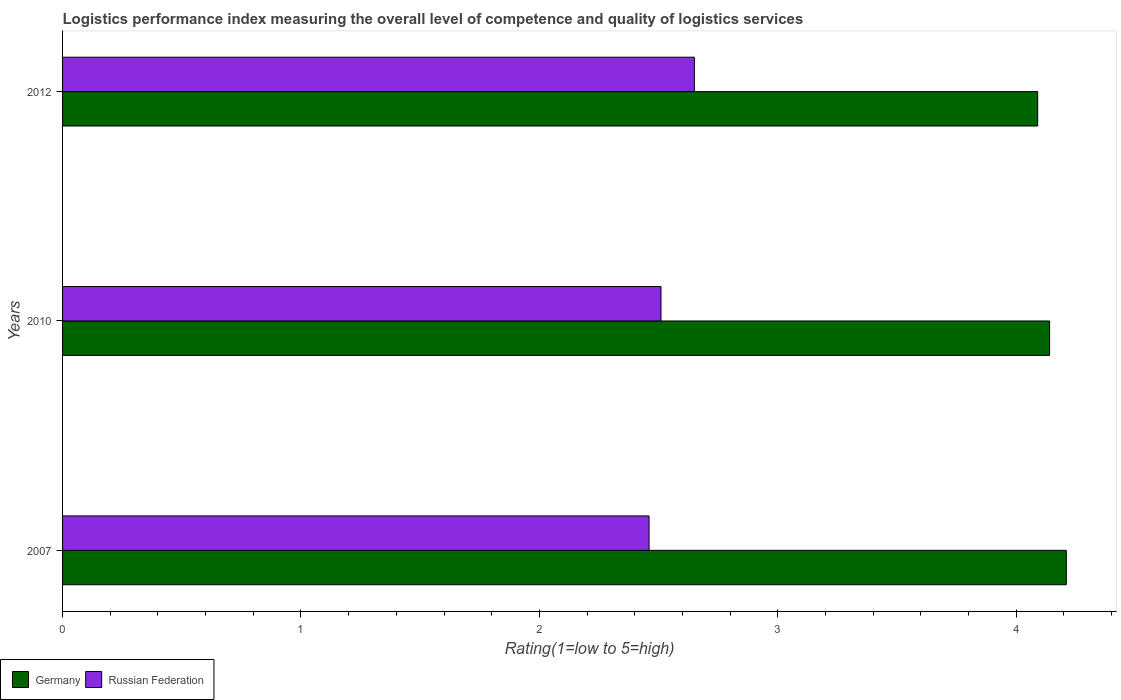How many different coloured bars are there?
Give a very brief answer. 2. How many groups of bars are there?
Your answer should be compact. 3. How many bars are there on the 3rd tick from the top?
Provide a short and direct response. 2. In how many cases, is the number of bars for a given year not equal to the number of legend labels?
Offer a very short reply. 0. What is the Logistic performance index in Germany in 2007?
Provide a succinct answer. 4.21. Across all years, what is the maximum Logistic performance index in Germany?
Provide a short and direct response. 4.21. Across all years, what is the minimum Logistic performance index in Russian Federation?
Make the answer very short. 2.46. In which year was the Logistic performance index in Germany maximum?
Keep it short and to the point. 2007. What is the total Logistic performance index in Germany in the graph?
Give a very brief answer. 12.44. What is the difference between the Logistic performance index in Germany in 2010 and that in 2012?
Provide a short and direct response. 0.05. What is the difference between the Logistic performance index in Germany in 2007 and the Logistic performance index in Russian Federation in 2012?
Your answer should be very brief. 1.56. What is the average Logistic performance index in Germany per year?
Your response must be concise. 4.15. In the year 2012, what is the difference between the Logistic performance index in Germany and Logistic performance index in Russian Federation?
Offer a terse response. 1.44. In how many years, is the Logistic performance index in Germany greater than 0.8 ?
Offer a very short reply. 3. What is the ratio of the Logistic performance index in Russian Federation in 2007 to that in 2010?
Provide a succinct answer. 0.98. Is the Logistic performance index in Russian Federation in 2007 less than that in 2012?
Keep it short and to the point. Yes. What is the difference between the highest and the second highest Logistic performance index in Germany?
Provide a short and direct response. 0.07. What is the difference between the highest and the lowest Logistic performance index in Russian Federation?
Ensure brevity in your answer.  0.19. Is the sum of the Logistic performance index in Germany in 2010 and 2012 greater than the maximum Logistic performance index in Russian Federation across all years?
Offer a terse response. Yes. What does the 2nd bar from the top in 2010 represents?
Ensure brevity in your answer.  Germany. What does the 2nd bar from the bottom in 2012 represents?
Your answer should be very brief. Russian Federation. How many bars are there?
Your response must be concise. 6. How many years are there in the graph?
Provide a short and direct response. 3. Are the values on the major ticks of X-axis written in scientific E-notation?
Ensure brevity in your answer.  No. Does the graph contain any zero values?
Offer a terse response. No. Where does the legend appear in the graph?
Offer a very short reply. Bottom left. What is the title of the graph?
Offer a terse response. Logistics performance index measuring the overall level of competence and quality of logistics services. What is the label or title of the X-axis?
Offer a very short reply. Rating(1=low to 5=high). What is the label or title of the Y-axis?
Your response must be concise. Years. What is the Rating(1=low to 5=high) of Germany in 2007?
Your response must be concise. 4.21. What is the Rating(1=low to 5=high) of Russian Federation in 2007?
Your response must be concise. 2.46. What is the Rating(1=low to 5=high) of Germany in 2010?
Your response must be concise. 4.14. What is the Rating(1=low to 5=high) of Russian Federation in 2010?
Your answer should be compact. 2.51. What is the Rating(1=low to 5=high) in Germany in 2012?
Ensure brevity in your answer.  4.09. What is the Rating(1=low to 5=high) of Russian Federation in 2012?
Your answer should be compact. 2.65. Across all years, what is the maximum Rating(1=low to 5=high) in Germany?
Offer a very short reply. 4.21. Across all years, what is the maximum Rating(1=low to 5=high) in Russian Federation?
Ensure brevity in your answer.  2.65. Across all years, what is the minimum Rating(1=low to 5=high) of Germany?
Your answer should be very brief. 4.09. Across all years, what is the minimum Rating(1=low to 5=high) in Russian Federation?
Offer a terse response. 2.46. What is the total Rating(1=low to 5=high) in Germany in the graph?
Give a very brief answer. 12.44. What is the total Rating(1=low to 5=high) of Russian Federation in the graph?
Give a very brief answer. 7.62. What is the difference between the Rating(1=low to 5=high) in Germany in 2007 and that in 2010?
Offer a very short reply. 0.07. What is the difference between the Rating(1=low to 5=high) in Germany in 2007 and that in 2012?
Provide a short and direct response. 0.12. What is the difference between the Rating(1=low to 5=high) of Russian Federation in 2007 and that in 2012?
Your response must be concise. -0.19. What is the difference between the Rating(1=low to 5=high) in Russian Federation in 2010 and that in 2012?
Offer a terse response. -0.14. What is the difference between the Rating(1=low to 5=high) in Germany in 2007 and the Rating(1=low to 5=high) in Russian Federation in 2010?
Offer a terse response. 1.7. What is the difference between the Rating(1=low to 5=high) of Germany in 2007 and the Rating(1=low to 5=high) of Russian Federation in 2012?
Your response must be concise. 1.56. What is the difference between the Rating(1=low to 5=high) of Germany in 2010 and the Rating(1=low to 5=high) of Russian Federation in 2012?
Offer a very short reply. 1.49. What is the average Rating(1=low to 5=high) of Germany per year?
Make the answer very short. 4.15. What is the average Rating(1=low to 5=high) of Russian Federation per year?
Give a very brief answer. 2.54. In the year 2007, what is the difference between the Rating(1=low to 5=high) in Germany and Rating(1=low to 5=high) in Russian Federation?
Your response must be concise. 1.75. In the year 2010, what is the difference between the Rating(1=low to 5=high) in Germany and Rating(1=low to 5=high) in Russian Federation?
Your response must be concise. 1.63. In the year 2012, what is the difference between the Rating(1=low to 5=high) of Germany and Rating(1=low to 5=high) of Russian Federation?
Give a very brief answer. 1.44. What is the ratio of the Rating(1=low to 5=high) of Germany in 2007 to that in 2010?
Keep it short and to the point. 1.02. What is the ratio of the Rating(1=low to 5=high) of Russian Federation in 2007 to that in 2010?
Offer a very short reply. 0.98. What is the ratio of the Rating(1=low to 5=high) of Germany in 2007 to that in 2012?
Keep it short and to the point. 1.03. What is the ratio of the Rating(1=low to 5=high) of Russian Federation in 2007 to that in 2012?
Keep it short and to the point. 0.93. What is the ratio of the Rating(1=low to 5=high) of Germany in 2010 to that in 2012?
Provide a short and direct response. 1.01. What is the ratio of the Rating(1=low to 5=high) of Russian Federation in 2010 to that in 2012?
Keep it short and to the point. 0.95. What is the difference between the highest and the second highest Rating(1=low to 5=high) of Germany?
Your response must be concise. 0.07. What is the difference between the highest and the second highest Rating(1=low to 5=high) of Russian Federation?
Offer a terse response. 0.14. What is the difference between the highest and the lowest Rating(1=low to 5=high) of Germany?
Your answer should be compact. 0.12. What is the difference between the highest and the lowest Rating(1=low to 5=high) in Russian Federation?
Offer a terse response. 0.19. 